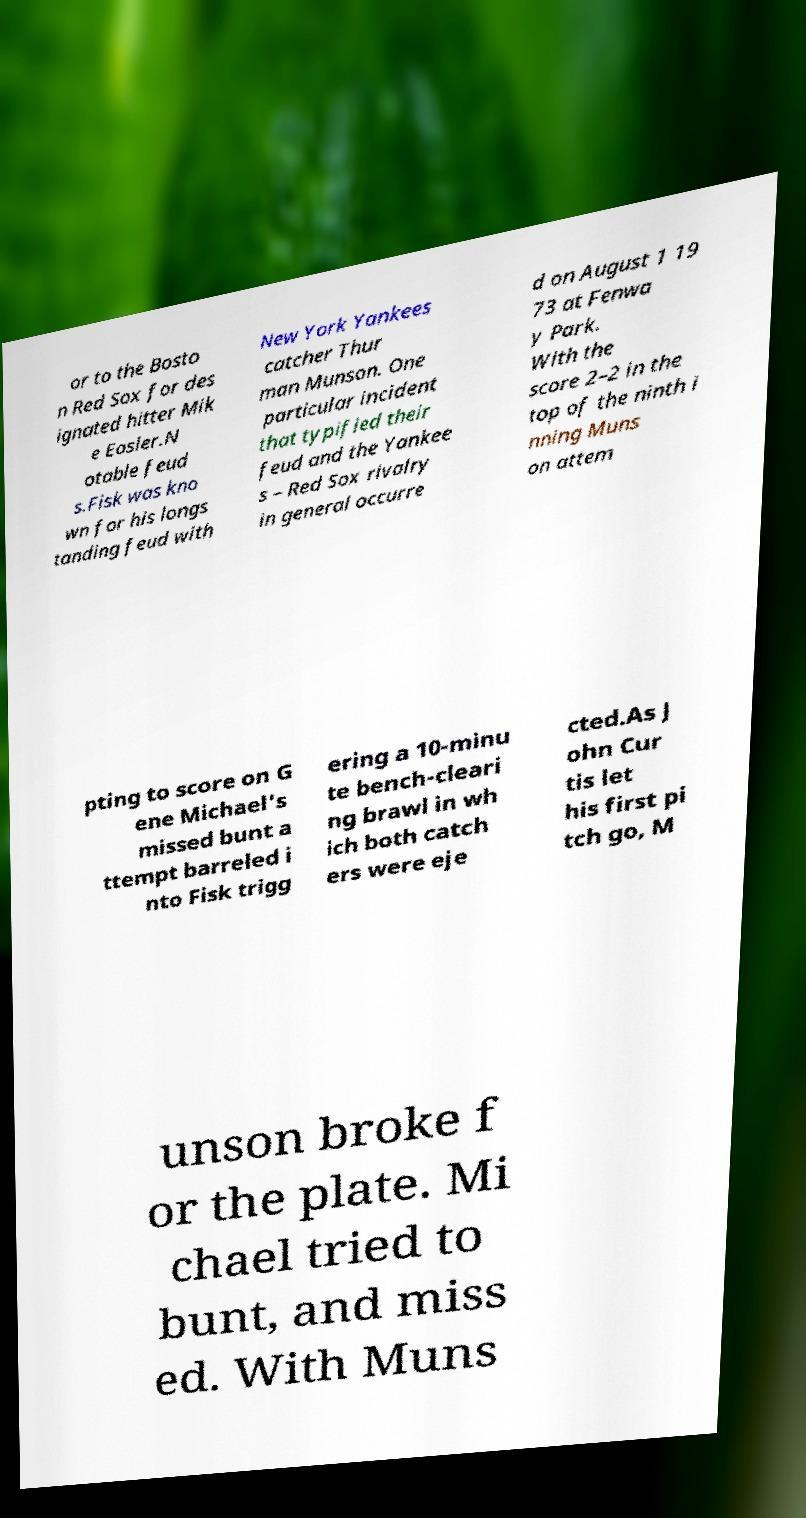Please read and relay the text visible in this image. What does it say? or to the Bosto n Red Sox for des ignated hitter Mik e Easler.N otable feud s.Fisk was kno wn for his longs tanding feud with New York Yankees catcher Thur man Munson. One particular incident that typified their feud and the Yankee s – Red Sox rivalry in general occurre d on August 1 19 73 at Fenwa y Park. With the score 2–2 in the top of the ninth i nning Muns on attem pting to score on G ene Michael's missed bunt a ttempt barreled i nto Fisk trigg ering a 10-minu te bench-cleari ng brawl in wh ich both catch ers were eje cted.As J ohn Cur tis let his first pi tch go, M unson broke f or the plate. Mi chael tried to bunt, and miss ed. With Muns 